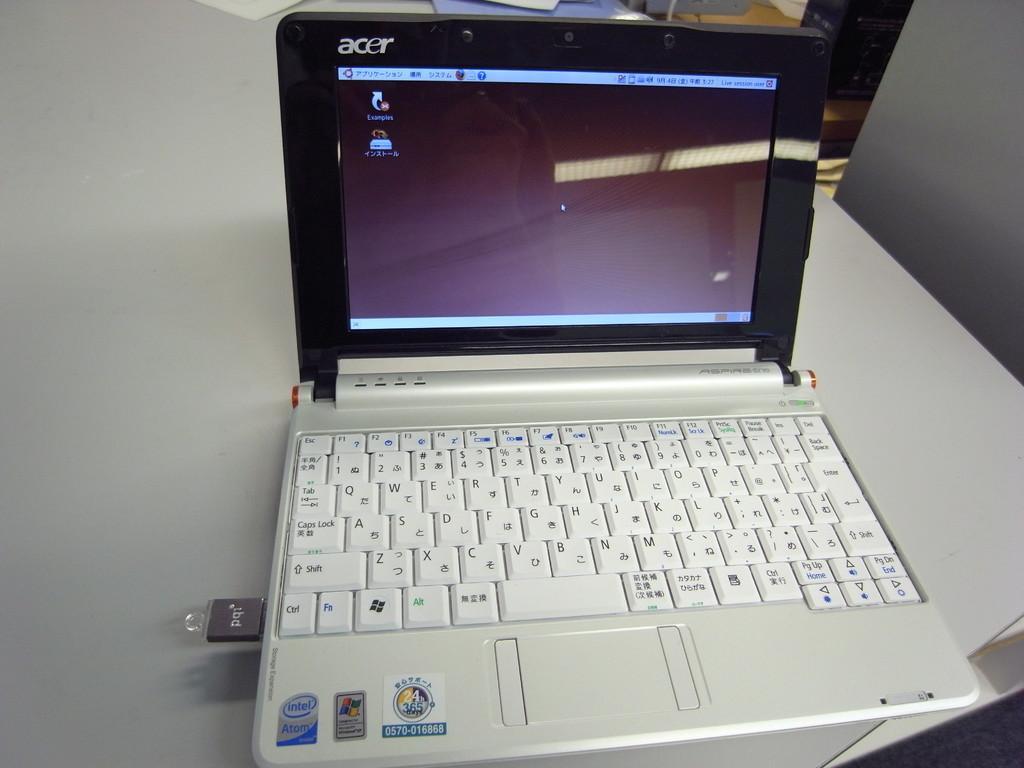How would you summarize this image in a sentence or two? In this image there is a laptop on the table with a pen drive plugged into it , and in the background there are some items. 